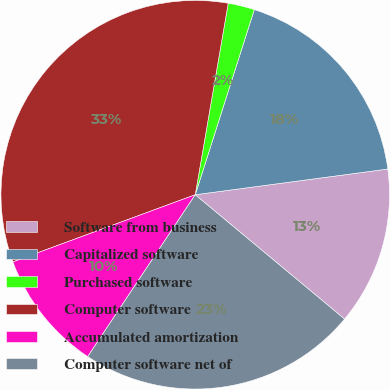Convert chart to OTSL. <chart><loc_0><loc_0><loc_500><loc_500><pie_chart><fcel>Software from business<fcel>Capitalized software<fcel>Purchased software<fcel>Computer software<fcel>Accumulated amortization<fcel>Computer software net of<nl><fcel>13.16%<fcel>17.97%<fcel>2.2%<fcel>33.33%<fcel>10.05%<fcel>23.28%<nl></chart> 